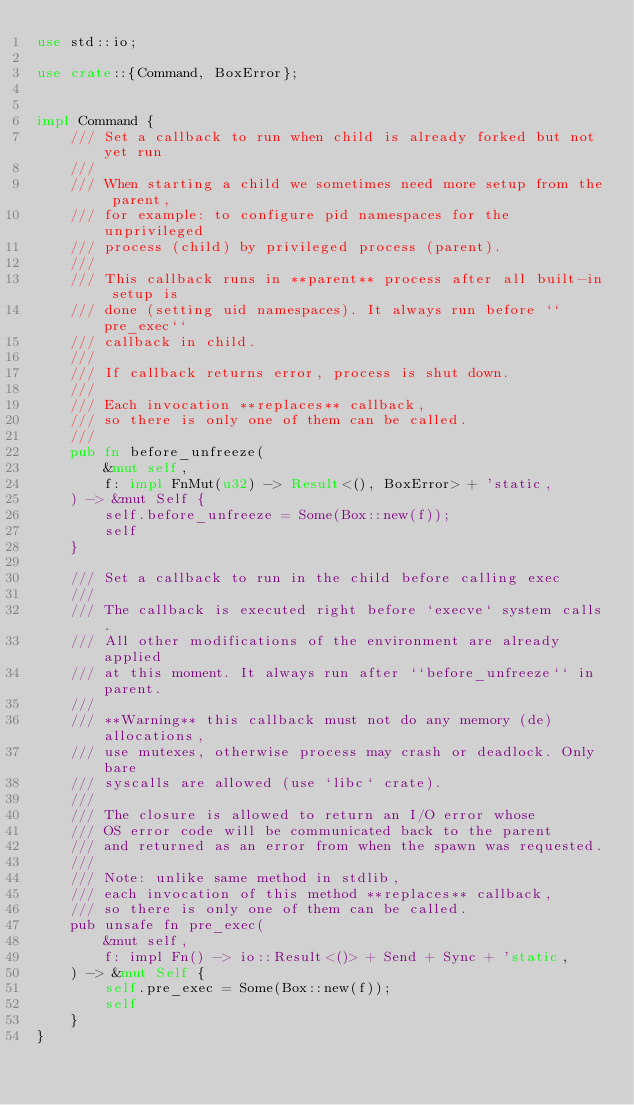<code> <loc_0><loc_0><loc_500><loc_500><_Rust_>use std::io;

use crate::{Command, BoxError};


impl Command {
    /// Set a callback to run when child is already forked but not yet run
    ///
    /// When starting a child we sometimes need more setup from the parent,
    /// for example: to configure pid namespaces for the unprivileged
    /// process (child) by privileged process (parent).
    ///
    /// This callback runs in **parent** process after all built-in setup is
    /// done (setting uid namespaces). It always run before ``pre_exec``
    /// callback in child.
    ///
    /// If callback returns error, process is shut down.
    ///
    /// Each invocation **replaces** callback,
    /// so there is only one of them can be called.
    ///
    pub fn before_unfreeze(
        &mut self,
        f: impl FnMut(u32) -> Result<(), BoxError> + 'static,
    ) -> &mut Self {
        self.before_unfreeze = Some(Box::new(f));
        self
    }

    /// Set a callback to run in the child before calling exec
    ///
    /// The callback is executed right before `execve` system calls.
    /// All other modifications of the environment are already applied
    /// at this moment. It always run after ``before_unfreeze`` in parent.
    ///
    /// **Warning** this callback must not do any memory (de)allocations,
    /// use mutexes, otherwise process may crash or deadlock. Only bare
    /// syscalls are allowed (use `libc` crate).
    ///
    /// The closure is allowed to return an I/O error whose
    /// OS error code will be communicated back to the parent
    /// and returned as an error from when the spawn was requested.
    ///
    /// Note: unlike same method in stdlib,
    /// each invocation of this method **replaces** callback,
    /// so there is only one of them can be called.
    pub unsafe fn pre_exec(
        &mut self,
        f: impl Fn() -> io::Result<()> + Send + Sync + 'static,
    ) -> &mut Self {
        self.pre_exec = Some(Box::new(f));
        self
    }
}
</code> 